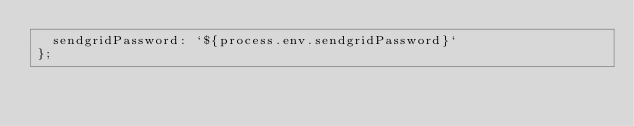Convert code to text. <code><loc_0><loc_0><loc_500><loc_500><_JavaScript_>  sendgridPassword: `${process.env.sendgridPassword}`
};</code> 